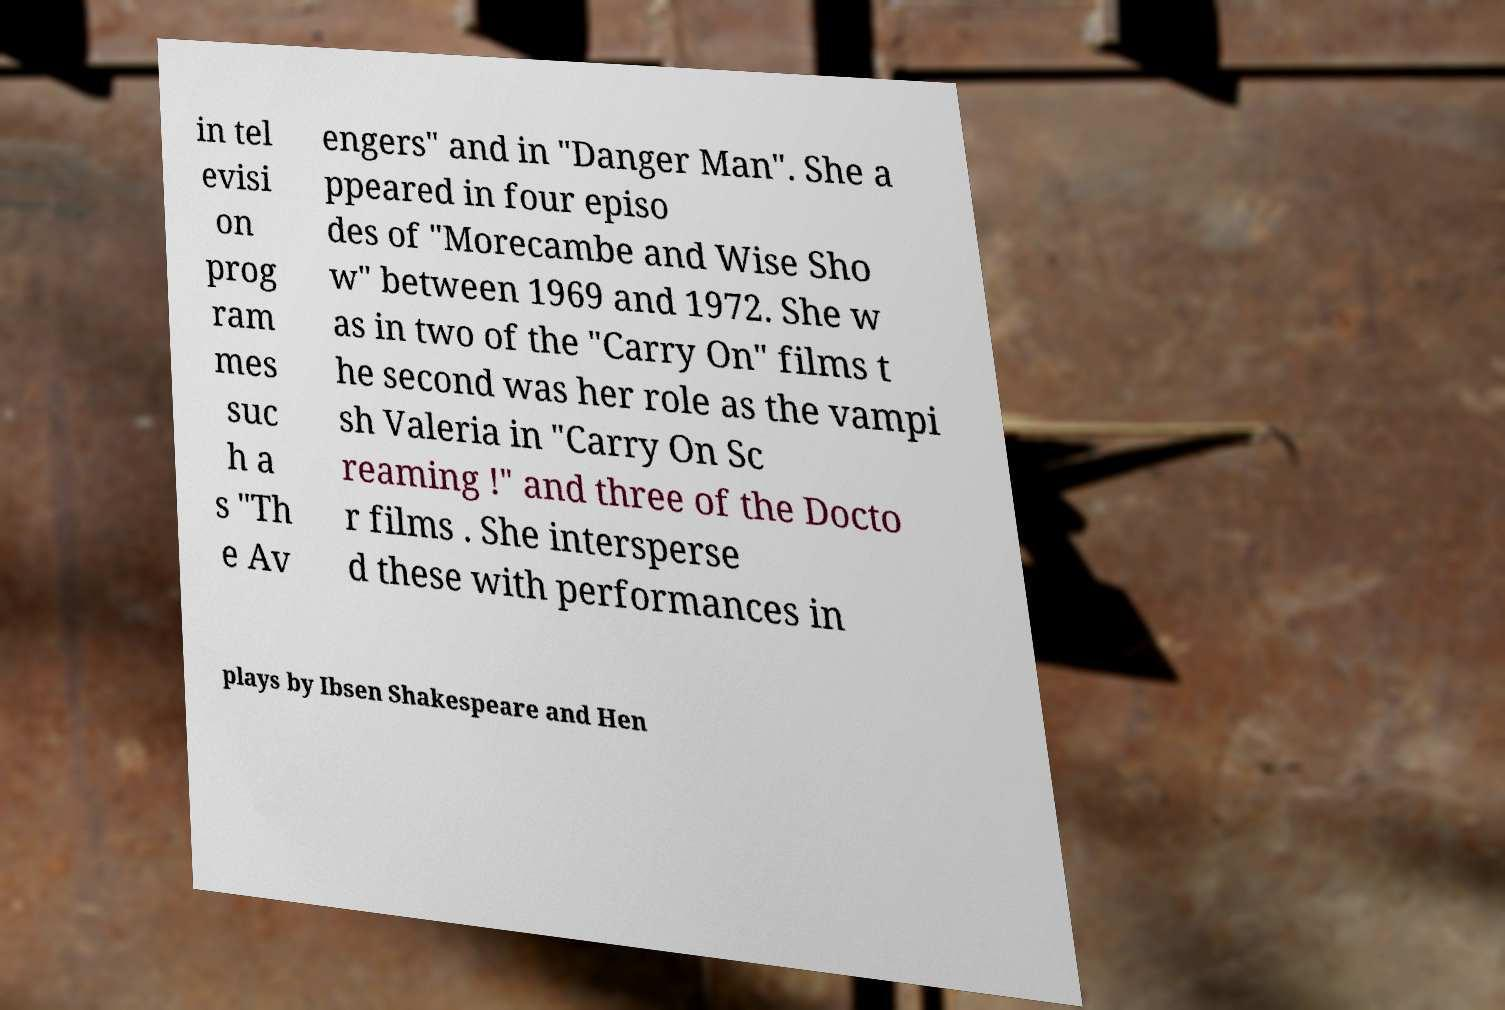Can you read and provide the text displayed in the image?This photo seems to have some interesting text. Can you extract and type it out for me? in tel evisi on prog ram mes suc h a s "Th e Av engers" and in "Danger Man". She a ppeared in four episo des of "Morecambe and Wise Sho w" between 1969 and 1972. She w as in two of the "Carry On" films t he second was her role as the vampi sh Valeria in "Carry On Sc reaming !" and three of the Docto r films . She intersperse d these with performances in plays by Ibsen Shakespeare and Hen 